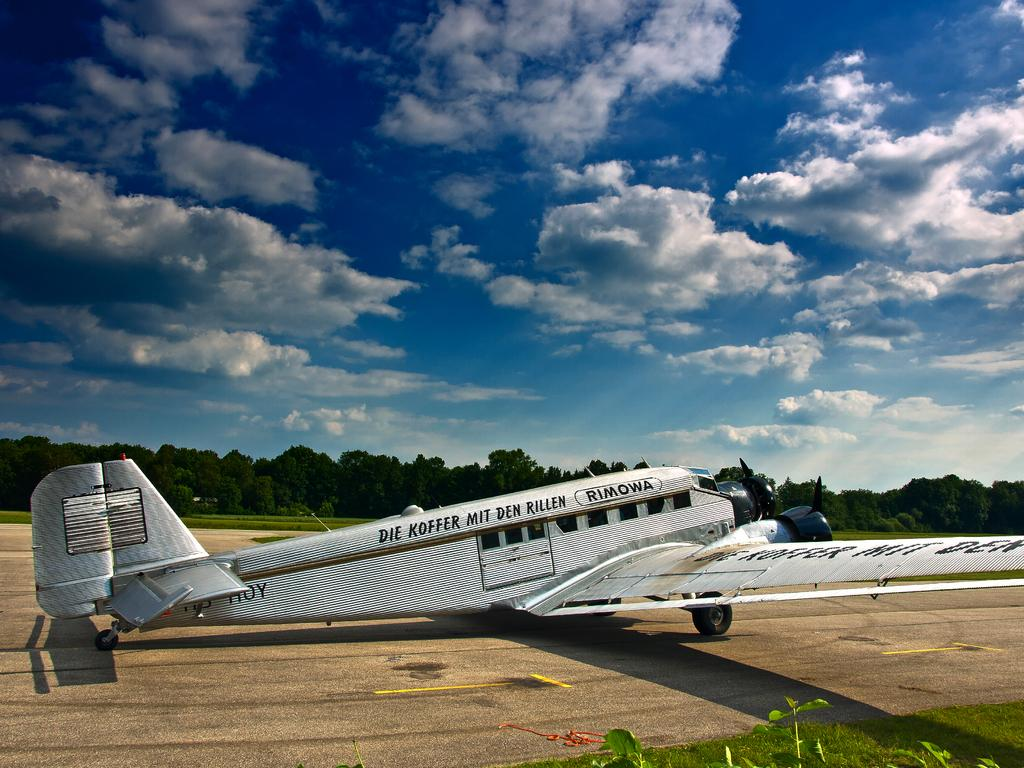<image>
Render a clear and concise summary of the photo. The airplane has the words "Die Koffer Mit Den Rillen" written on it. 